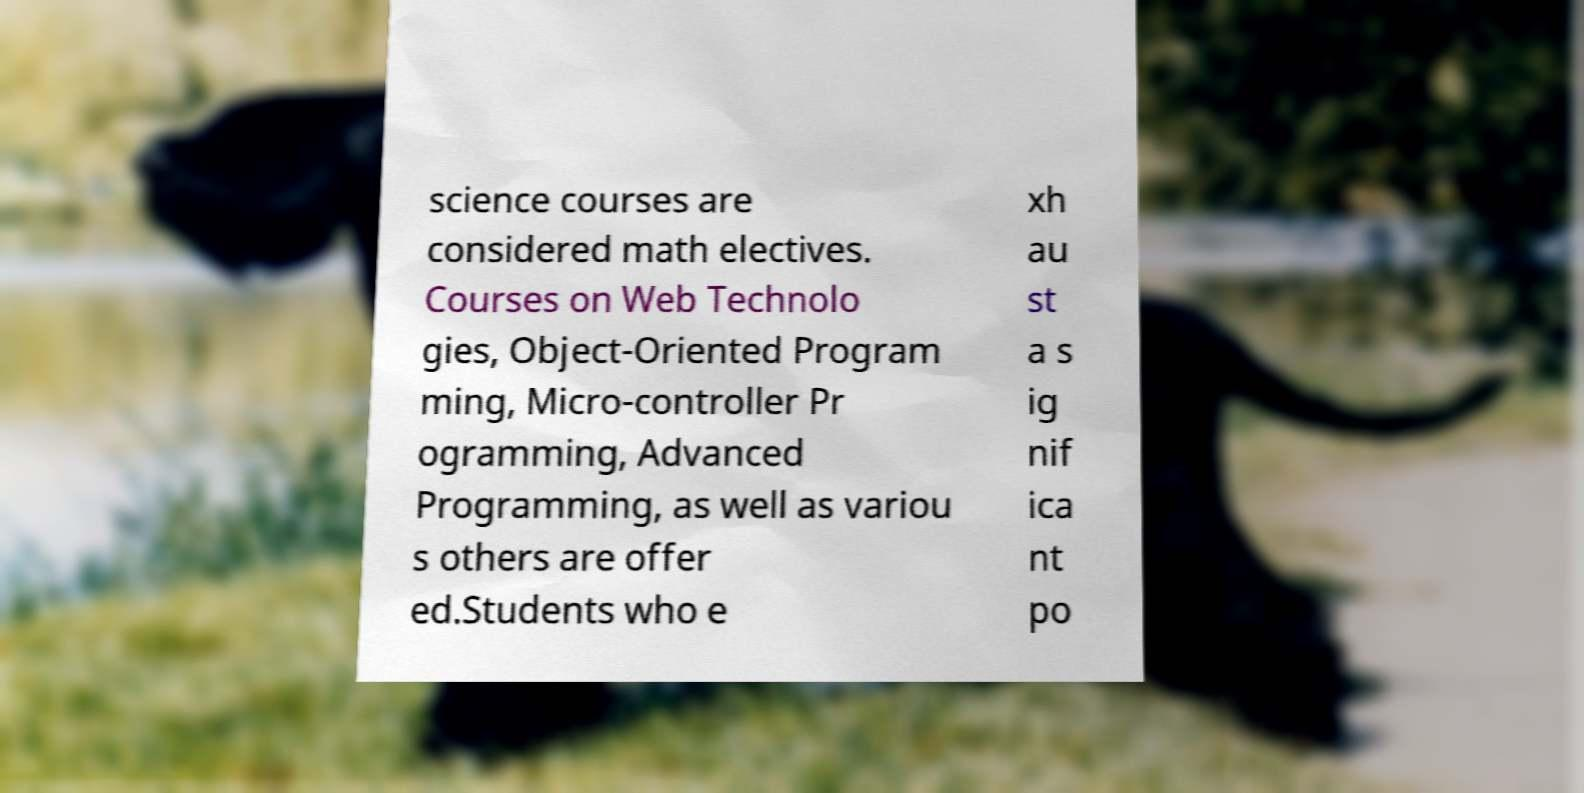Could you assist in decoding the text presented in this image and type it out clearly? science courses are considered math electives. Courses on Web Technolo gies, Object-Oriented Program ming, Micro-controller Pr ogramming, Advanced Programming, as well as variou s others are offer ed.Students who e xh au st a s ig nif ica nt po 